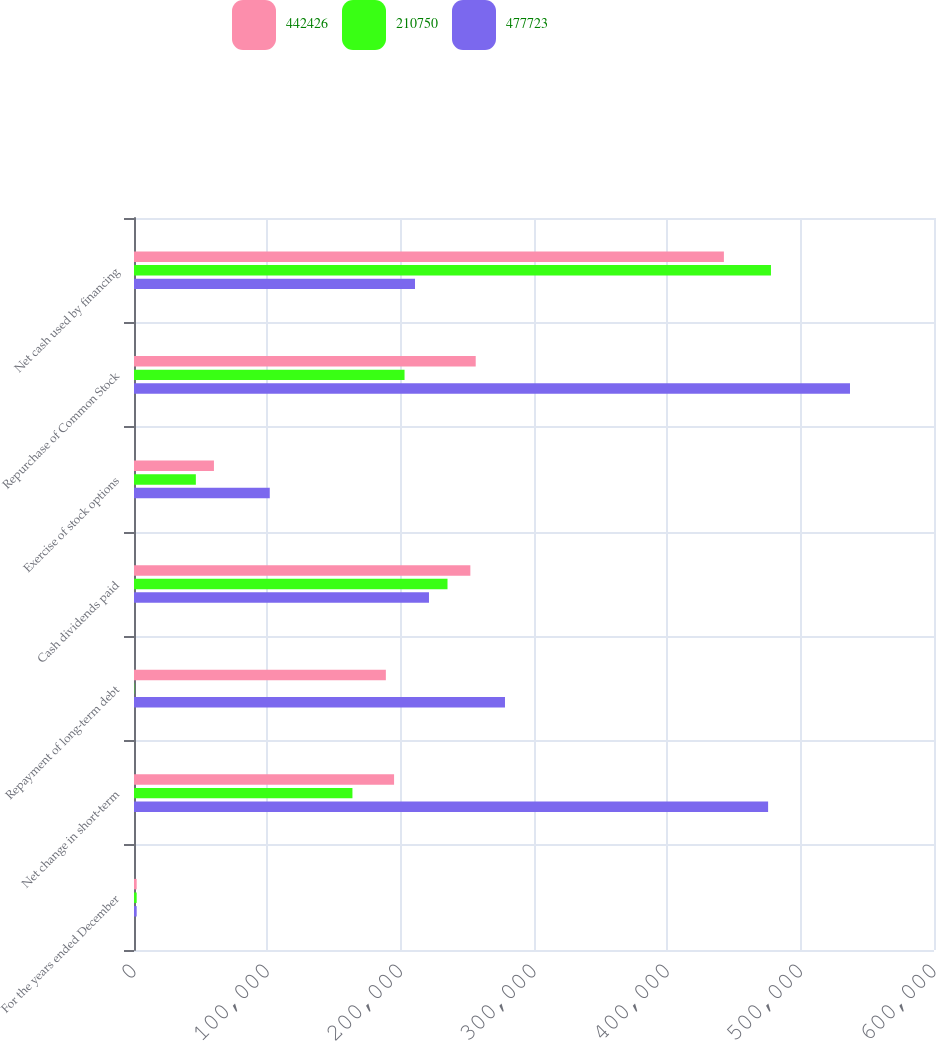<chart> <loc_0><loc_0><loc_500><loc_500><stacked_bar_chart><ecel><fcel>For the years ended December<fcel>Net change in short-term<fcel>Repayment of long-term debt<fcel>Cash dividends paid<fcel>Exercise of stock options<fcel>Repurchase of Common Stock<fcel>Net cash used by financing<nl><fcel>442426<fcel>2007<fcel>195055<fcel>188891<fcel>252263<fcel>59958<fcel>256285<fcel>442426<nl><fcel>210750<fcel>2006<fcel>163826<fcel>234<fcel>235129<fcel>46386<fcel>202902<fcel>477723<nl><fcel>477723<fcel>2005<fcel>475582<fcel>278236<fcel>221235<fcel>101818<fcel>536997<fcel>210750<nl></chart> 